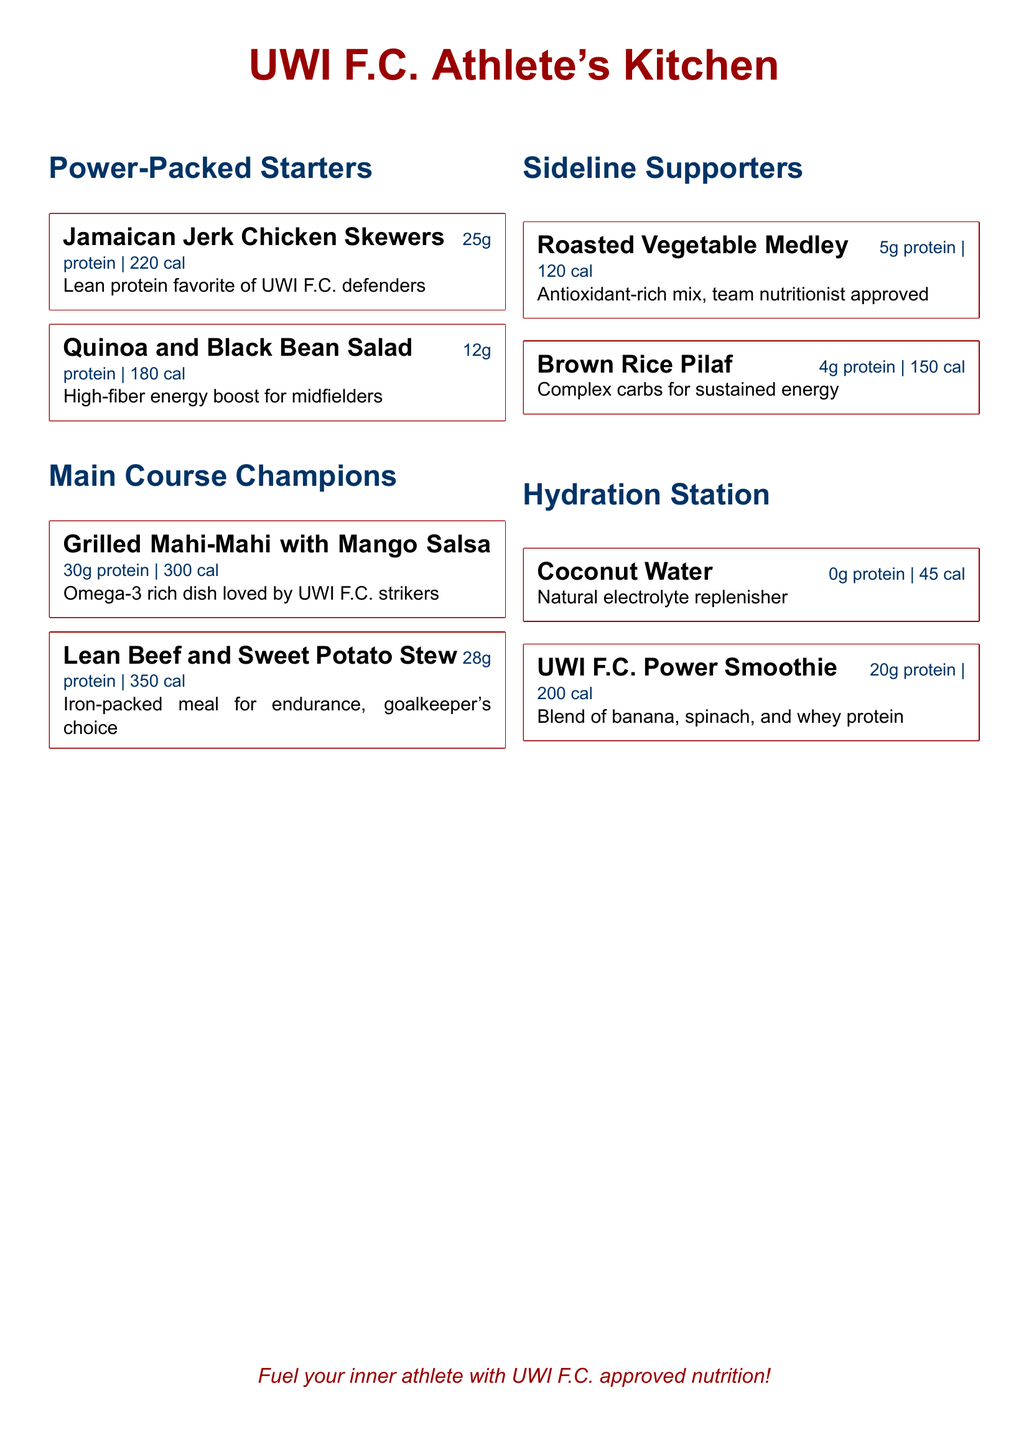What is the protein content of the Jamaican Jerk Chicken Skewers? The Jamaican Jerk Chicken Skewers contain 25g of protein as stated in the menu.
Answer: 25g How many calories are in the Grilled Mahi-Mahi with Mango Salsa? The Grilled Mahi-Mahi with Mango Salsa has 300 calories, which is clearly mentioned in the menu.
Answer: 300 What is a key nutritional benefit of the Quinoa and Black Bean Salad? The Quinoa and Black Bean Salad is described as a high-fiber energy boost for midfielders, highlighting its nutritional advantage.
Answer: High-fiber Which main course is specifically described as a goalkeeper's choice? The Lean Beef and Sweet Potato Stew is identified as the goalkeeper's choice in the menu.
Answer: Lean Beef and Sweet Potato Stew What drink is known as a natural electrolyte replenisher? Coconut Water is mentioned in the menu as a natural electrolyte replenisher.
Answer: Coconut Water Which menu item has the lowest calorie count? The Roasted Vegetable Medley has the lowest calorie count at 120 calories.
Answer: 120 How much protein is in the UWI F.C. Power Smoothie? The UWI F.C. Power Smoothie contains 20g of protein according to the menu details.
Answer: 20g What is the calorie count for Brown Rice Pilaf? The menu states that Brown Rice Pilaf contains 150 calories.
Answer: 150 Which category includes antioxidant-rich options? The Sideline Supporters category includes antioxidant-rich options as indicated in the menu.
Answer: Sideline Supporters 